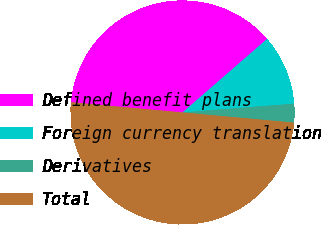<chart> <loc_0><loc_0><loc_500><loc_500><pie_chart><fcel>Defined benefit plans<fcel>Foreign currency translation<fcel>Derivatives<fcel>Total<nl><fcel>37.16%<fcel>10.14%<fcel>2.7%<fcel>50.0%<nl></chart> 